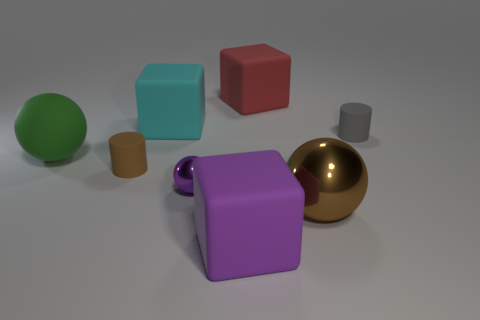Subtract all big shiny spheres. How many spheres are left? 2 Subtract all gray cylinders. How many cylinders are left? 1 Subtract all cubes. How many objects are left? 5 Add 5 large rubber spheres. How many large rubber spheres are left? 6 Add 2 tiny gray rubber objects. How many tiny gray rubber objects exist? 3 Add 1 tiny spheres. How many objects exist? 9 Subtract 0 yellow spheres. How many objects are left? 8 Subtract 1 cylinders. How many cylinders are left? 1 Subtract all green cubes. Subtract all purple cylinders. How many cubes are left? 3 Subtract all blue blocks. How many yellow cylinders are left? 0 